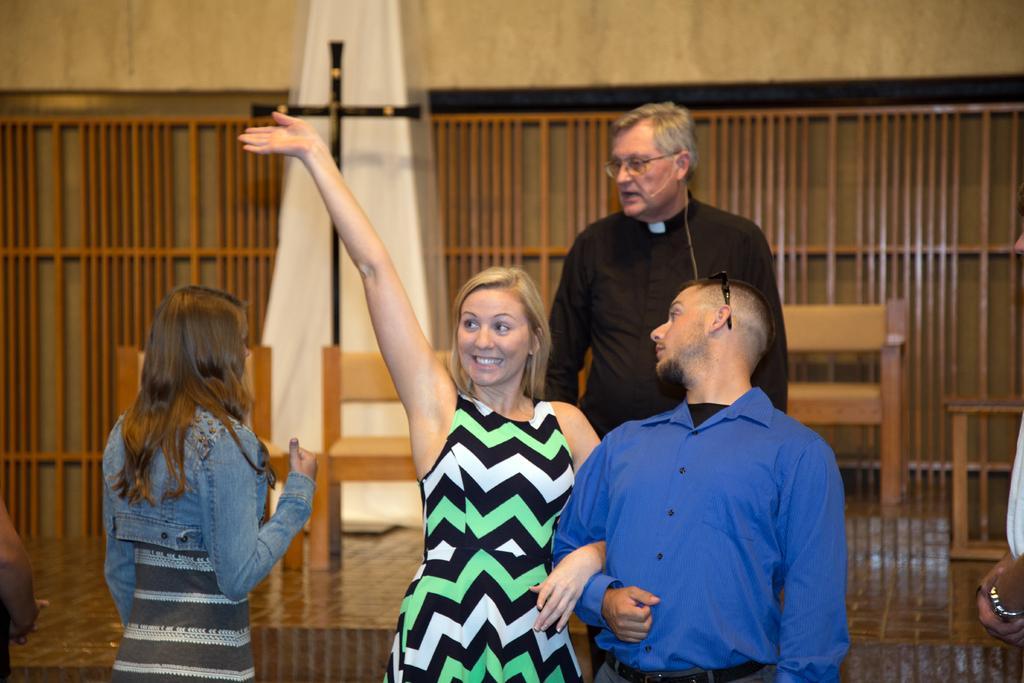Can you describe this image briefly? In this image we can see a group of people standing. On the backside we can see a cross, some chairs, cloth, some wooden poles and a wall. 